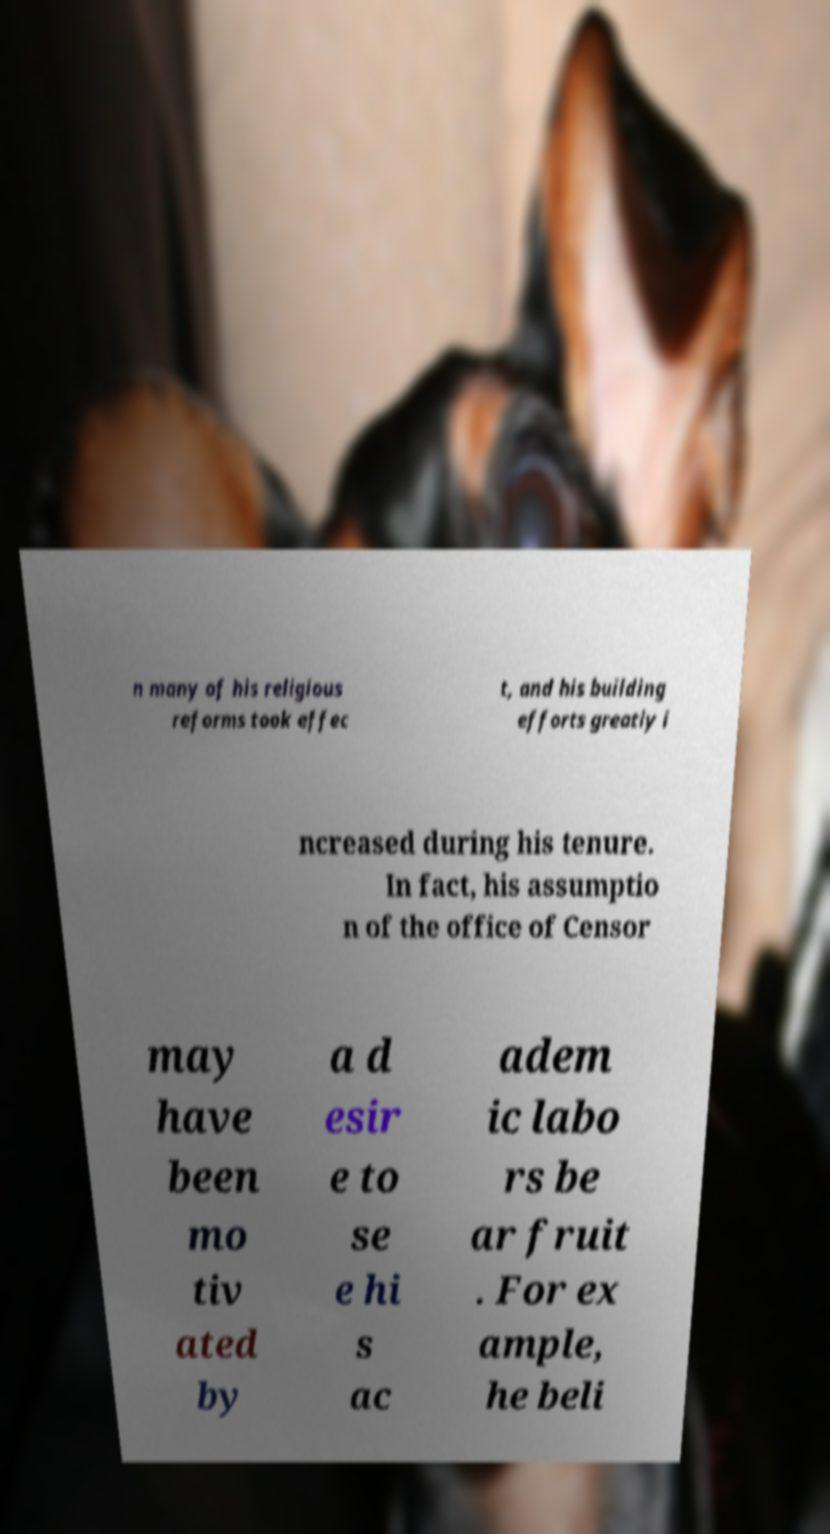Can you read and provide the text displayed in the image?This photo seems to have some interesting text. Can you extract and type it out for me? n many of his religious reforms took effec t, and his building efforts greatly i ncreased during his tenure. In fact, his assumptio n of the office of Censor may have been mo tiv ated by a d esir e to se e hi s ac adem ic labo rs be ar fruit . For ex ample, he beli 